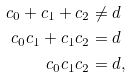<formula> <loc_0><loc_0><loc_500><loc_500>c _ { 0 } + c _ { 1 } + c _ { 2 } & \neq d \\ c _ { 0 } c _ { 1 } + c _ { 1 } c _ { 2 } & = d \\ c _ { 0 } c _ { 1 } c _ { 2 } & = d ,</formula> 